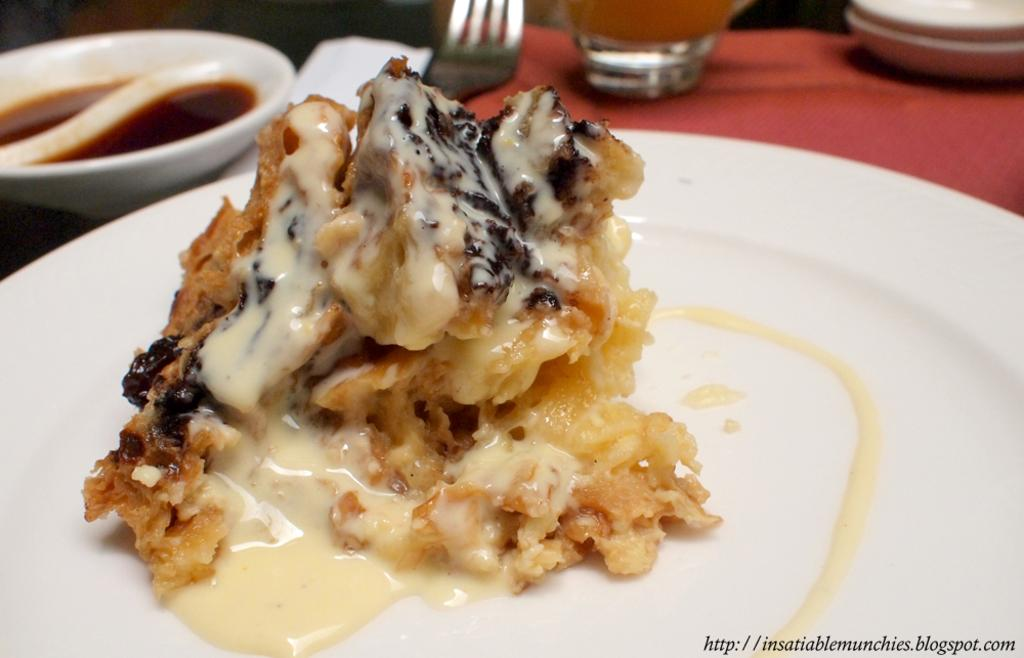What is on the plate in the image? There are food items on a plate in the image. What is in the bowl in the image? There are food items in a bowl in the image. What utensils are present in the image? There is a spoon and a fork in the image. What is the glass used for in the image? The glass is likely used for holding a beverage. What object is on the table in the image? There is an object on the table in the image, but its specific nature is not mentioned in the facts. Is there any indication of the image's origin or source? Yes, there is a watermark on the image. How many lines of snow can be seen in the image? There is no mention of lines or snow in the image; it features food items, utensils, and a glass on a table. What degree of temperature is required to melt the ice in the image? There is no ice present in the image, so the degree of temperature needed to melt it cannot be determined. 